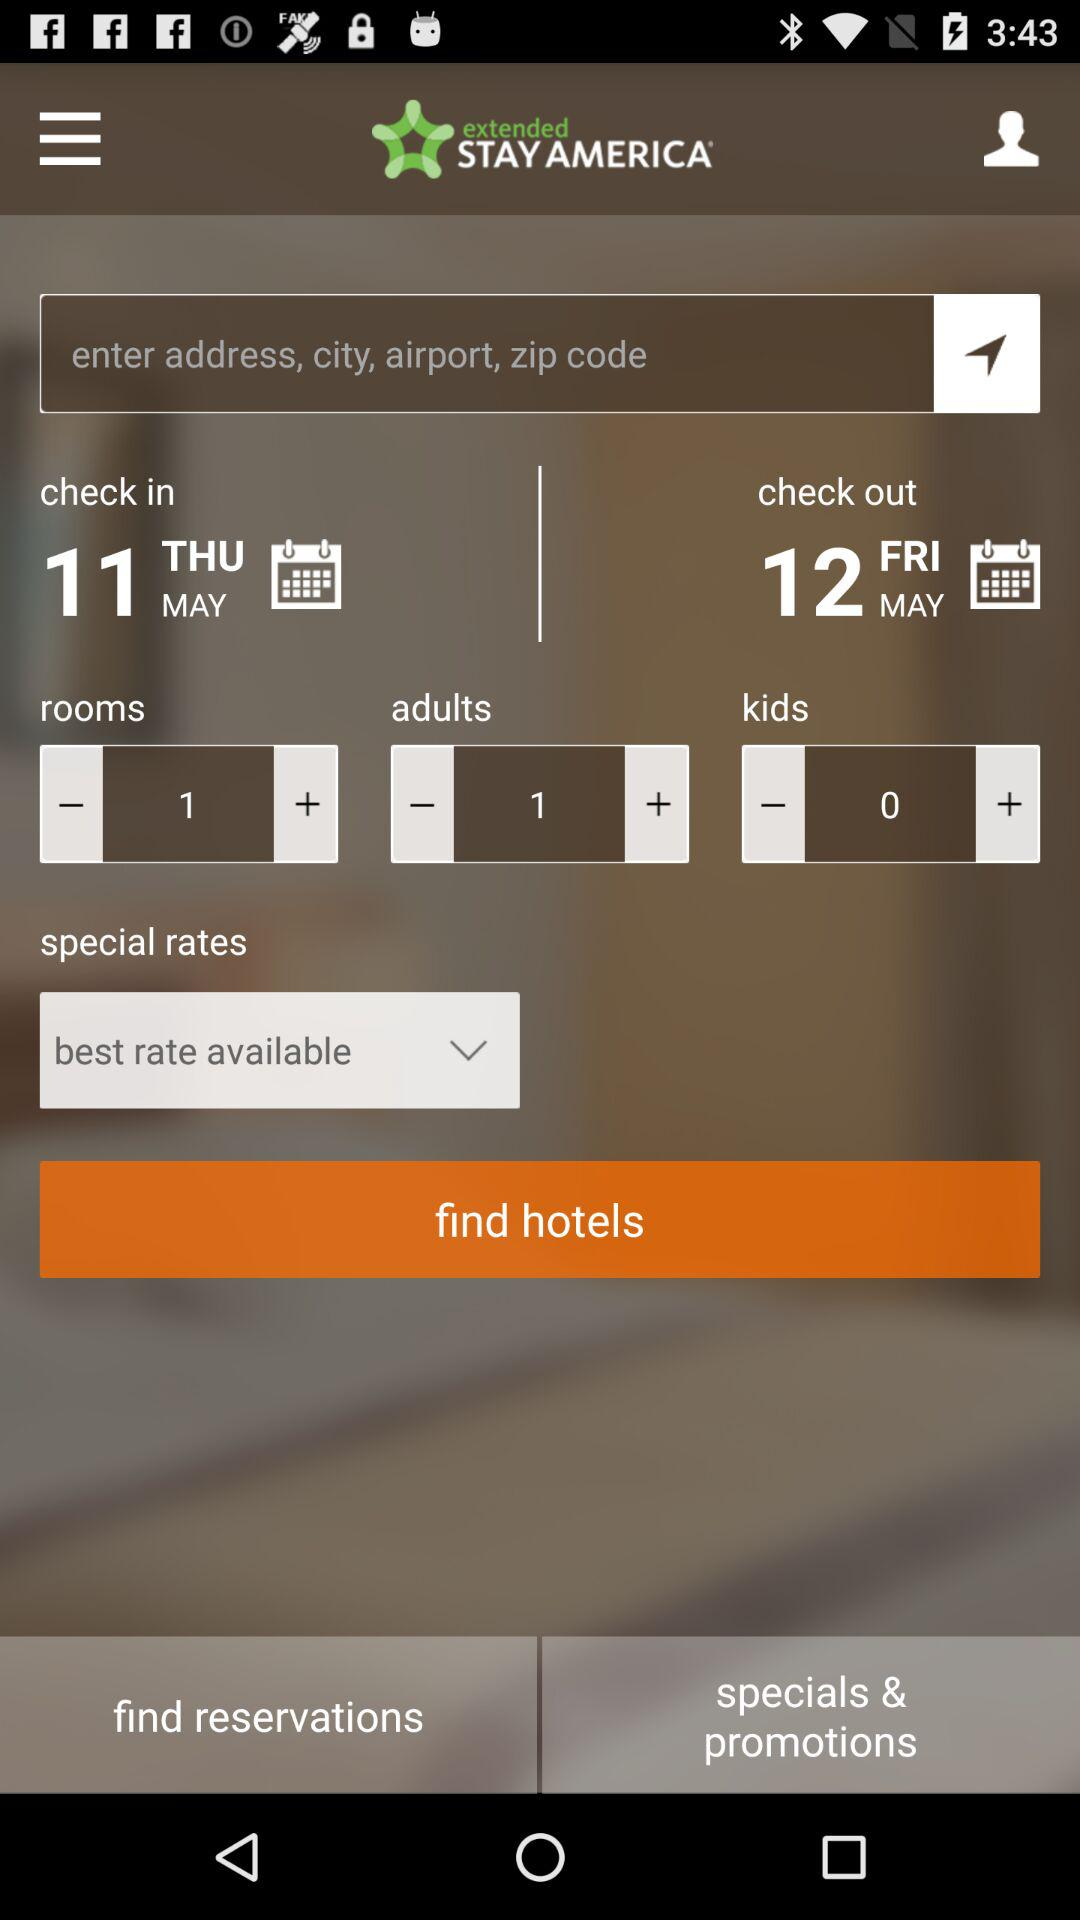How many days apart are the check in and check out dates?
Answer the question using a single word or phrase. 1 